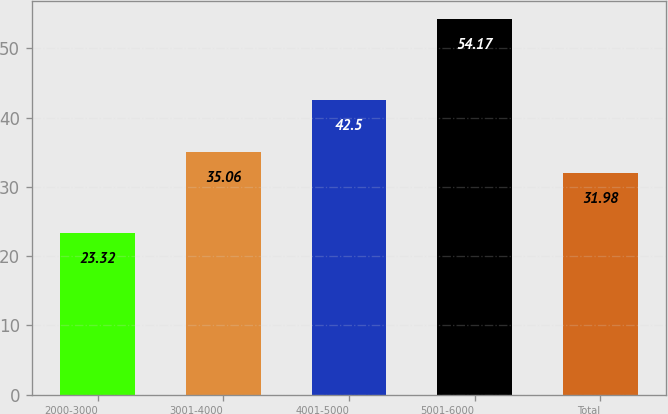Convert chart. <chart><loc_0><loc_0><loc_500><loc_500><bar_chart><fcel>2000-3000<fcel>3001-4000<fcel>4001-5000<fcel>5001-6000<fcel>Total<nl><fcel>23.32<fcel>35.06<fcel>42.5<fcel>54.17<fcel>31.98<nl></chart> 